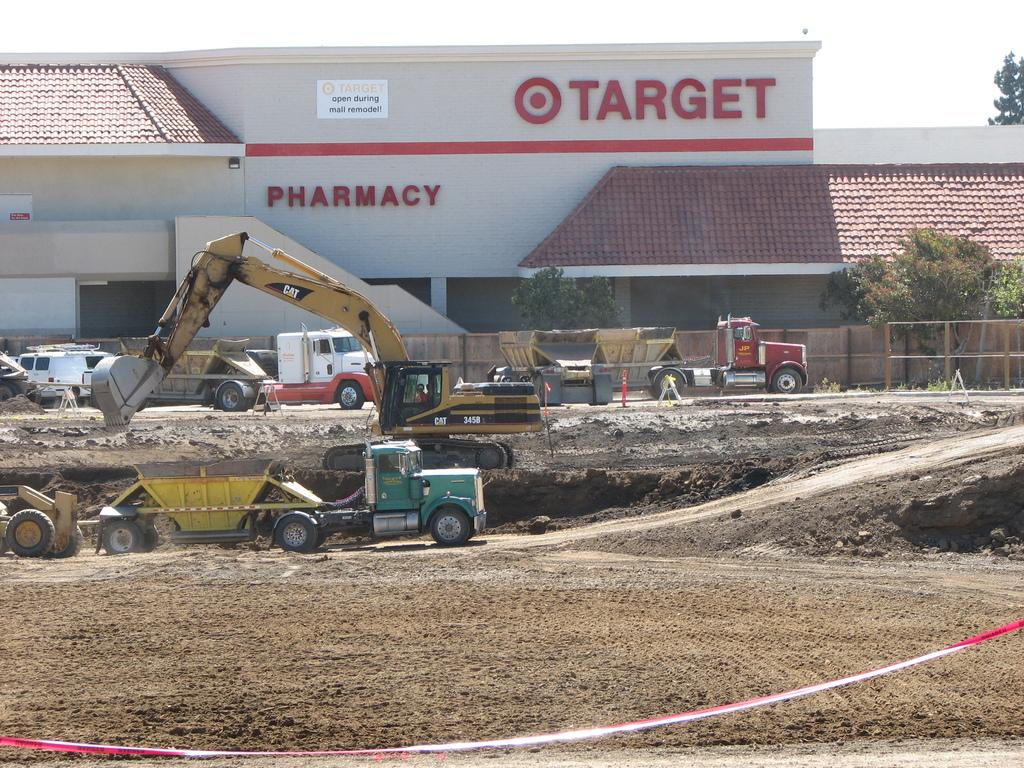What can be seen on the ground in the image? There are vehicles on the ground in the image. What objects are present in the background of the image? There are traffic cones, a ribbon, a building, and trees in the background of the image. What type of barrier is visible in the image? There is a fence in the image. What type of metal is the mind made of in the image? There is no mention of a mind or metal in the image; it features vehicles, traffic cones, a ribbon, a building, trees, and a fence. What type of shade is provided by the trees in the image? The image does not show the trees providing shade; it only shows their presence in the background. 